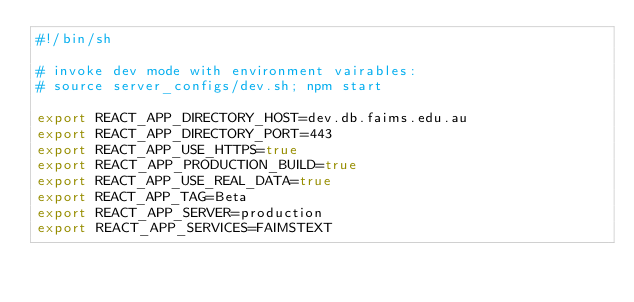Convert code to text. <code><loc_0><loc_0><loc_500><loc_500><_Bash_>#!/bin/sh

# invoke dev mode with environment vairables:
# source server_configs/dev.sh; npm start

export REACT_APP_DIRECTORY_HOST=dev.db.faims.edu.au
export REACT_APP_DIRECTORY_PORT=443
export REACT_APP_USE_HTTPS=true
export REACT_APP_PRODUCTION_BUILD=true
export REACT_APP_USE_REAL_DATA=true
export REACT_APP_TAG=Beta
export REACT_APP_SERVER=production
export REACT_APP_SERVICES=FAIMSTEXT</code> 